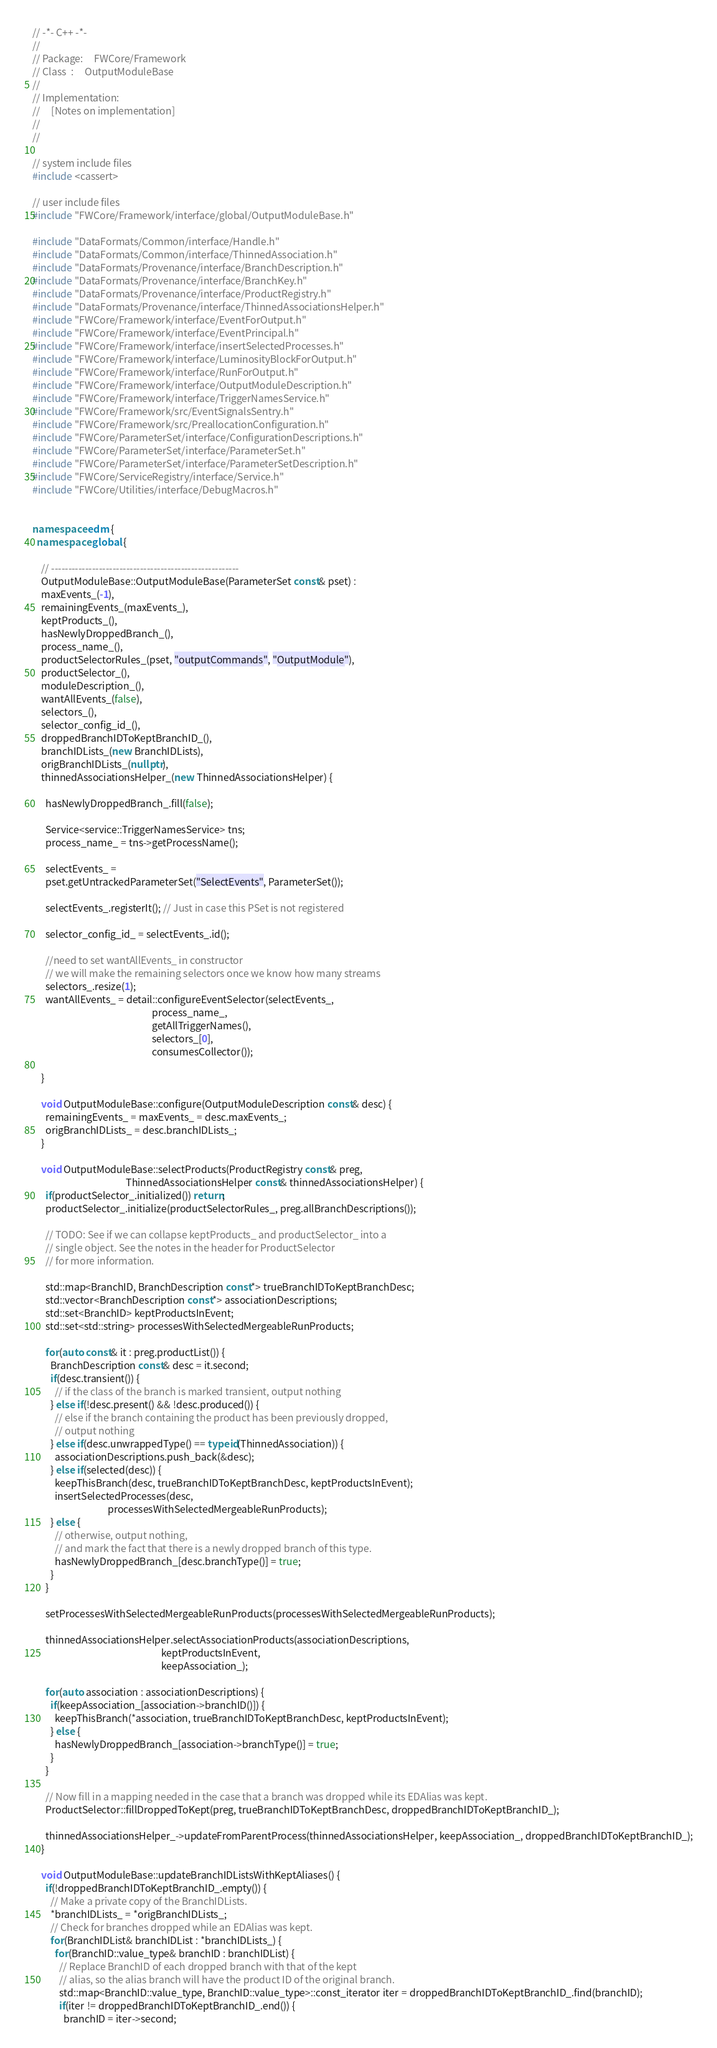Convert code to text. <code><loc_0><loc_0><loc_500><loc_500><_C++_>// -*- C++ -*-
//
// Package:     FWCore/Framework
// Class  :     OutputModuleBase
// 
// Implementation:
//     [Notes on implementation]
//
//

// system include files
#include <cassert>

// user include files
#include "FWCore/Framework/interface/global/OutputModuleBase.h"

#include "DataFormats/Common/interface/Handle.h"
#include "DataFormats/Common/interface/ThinnedAssociation.h"
#include "DataFormats/Provenance/interface/BranchDescription.h"
#include "DataFormats/Provenance/interface/BranchKey.h"
#include "DataFormats/Provenance/interface/ProductRegistry.h"
#include "DataFormats/Provenance/interface/ThinnedAssociationsHelper.h"
#include "FWCore/Framework/interface/EventForOutput.h"
#include "FWCore/Framework/interface/EventPrincipal.h"
#include "FWCore/Framework/interface/insertSelectedProcesses.h"
#include "FWCore/Framework/interface/LuminosityBlockForOutput.h"
#include "FWCore/Framework/interface/RunForOutput.h"
#include "FWCore/Framework/interface/OutputModuleDescription.h"
#include "FWCore/Framework/interface/TriggerNamesService.h"
#include "FWCore/Framework/src/EventSignalsSentry.h"
#include "FWCore/Framework/src/PreallocationConfiguration.h"
#include "FWCore/ParameterSet/interface/ConfigurationDescriptions.h"
#include "FWCore/ParameterSet/interface/ParameterSet.h"
#include "FWCore/ParameterSet/interface/ParameterSetDescription.h"
#include "FWCore/ServiceRegistry/interface/Service.h"
#include "FWCore/Utilities/interface/DebugMacros.h"


namespace edm {
  namespace global {

    // -------------------------------------------------------
    OutputModuleBase::OutputModuleBase(ParameterSet const& pset) :
    maxEvents_(-1),
    remainingEvents_(maxEvents_),
    keptProducts_(),
    hasNewlyDroppedBranch_(),
    process_name_(),
    productSelectorRules_(pset, "outputCommands", "OutputModule"),
    productSelector_(),
    moduleDescription_(),
    wantAllEvents_(false),
    selectors_(),
    selector_config_id_(),
    droppedBranchIDToKeptBranchID_(),
    branchIDLists_(new BranchIDLists),
    origBranchIDLists_(nullptr),
    thinnedAssociationsHelper_(new ThinnedAssociationsHelper) {
      
      hasNewlyDroppedBranch_.fill(false);
      
      Service<service::TriggerNamesService> tns;
      process_name_ = tns->getProcessName();
      
      selectEvents_ =
      pset.getUntrackedParameterSet("SelectEvents", ParameterSet());
      
      selectEvents_.registerIt(); // Just in case this PSet is not registered
      
      selector_config_id_ = selectEvents_.id();
      
      //need to set wantAllEvents_ in constructor
      // we will make the remaining selectors once we know how many streams
      selectors_.resize(1);
      wantAllEvents_ = detail::configureEventSelector(selectEvents_,
                                                      process_name_,
                                                      getAllTriggerNames(),
                                                      selectors_[0],
                                                      consumesCollector());

    }
    
    void OutputModuleBase::configure(OutputModuleDescription const& desc) {
      remainingEvents_ = maxEvents_ = desc.maxEvents_;
      origBranchIDLists_ = desc.branchIDLists_;
    }
    
    void OutputModuleBase::selectProducts(ProductRegistry const& preg,
                                          ThinnedAssociationsHelper const& thinnedAssociationsHelper) {
      if(productSelector_.initialized()) return;
      productSelector_.initialize(productSelectorRules_, preg.allBranchDescriptions());
      
      // TODO: See if we can collapse keptProducts_ and productSelector_ into a
      // single object. See the notes in the header for ProductSelector
      // for more information.
      
      std::map<BranchID, BranchDescription const*> trueBranchIDToKeptBranchDesc;
      std::vector<BranchDescription const*> associationDescriptions;
      std::set<BranchID> keptProductsInEvent;
      std::set<std::string> processesWithSelectedMergeableRunProducts;

      for(auto const& it : preg.productList()) {
        BranchDescription const& desc = it.second;
        if(desc.transient()) {
          // if the class of the branch is marked transient, output nothing
        } else if(!desc.present() && !desc.produced()) {
          // else if the branch containing the product has been previously dropped,
          // output nothing
        } else if(desc.unwrappedType() == typeid(ThinnedAssociation)) {
          associationDescriptions.push_back(&desc);
        } else if(selected(desc)) {
          keepThisBranch(desc, trueBranchIDToKeptBranchDesc, keptProductsInEvent);
          insertSelectedProcesses(desc,
                                  processesWithSelectedMergeableRunProducts);
        } else {
          // otherwise, output nothing,
          // and mark the fact that there is a newly dropped branch of this type.
          hasNewlyDroppedBranch_[desc.branchType()] = true;
        }
      }

      setProcessesWithSelectedMergeableRunProducts(processesWithSelectedMergeableRunProducts);

      thinnedAssociationsHelper.selectAssociationProducts(associationDescriptions,
                                                          keptProductsInEvent,
                                                          keepAssociation_);

      for(auto association : associationDescriptions) {
        if(keepAssociation_[association->branchID()]) {
          keepThisBranch(*association, trueBranchIDToKeptBranchDesc, keptProductsInEvent);
        } else {
          hasNewlyDroppedBranch_[association->branchType()] = true;
        }
      }

      // Now fill in a mapping needed in the case that a branch was dropped while its EDAlias was kept.
      ProductSelector::fillDroppedToKept(preg, trueBranchIDToKeptBranchDesc, droppedBranchIDToKeptBranchID_);

      thinnedAssociationsHelper_->updateFromParentProcess(thinnedAssociationsHelper, keepAssociation_, droppedBranchIDToKeptBranchID_);
    }

    void OutputModuleBase::updateBranchIDListsWithKeptAliases() {
      if(!droppedBranchIDToKeptBranchID_.empty()) {
        // Make a private copy of the BranchIDLists.
        *branchIDLists_ = *origBranchIDLists_;
        // Check for branches dropped while an EDAlias was kept.
        for(BranchIDList& branchIDList : *branchIDLists_) {
          for(BranchID::value_type& branchID : branchIDList) {
            // Replace BranchID of each dropped branch with that of the kept
            // alias, so the alias branch will have the product ID of the original branch.
            std::map<BranchID::value_type, BranchID::value_type>::const_iterator iter = droppedBranchIDToKeptBranchID_.find(branchID);
            if(iter != droppedBranchIDToKeptBranchID_.end()) {
              branchID = iter->second;</code> 